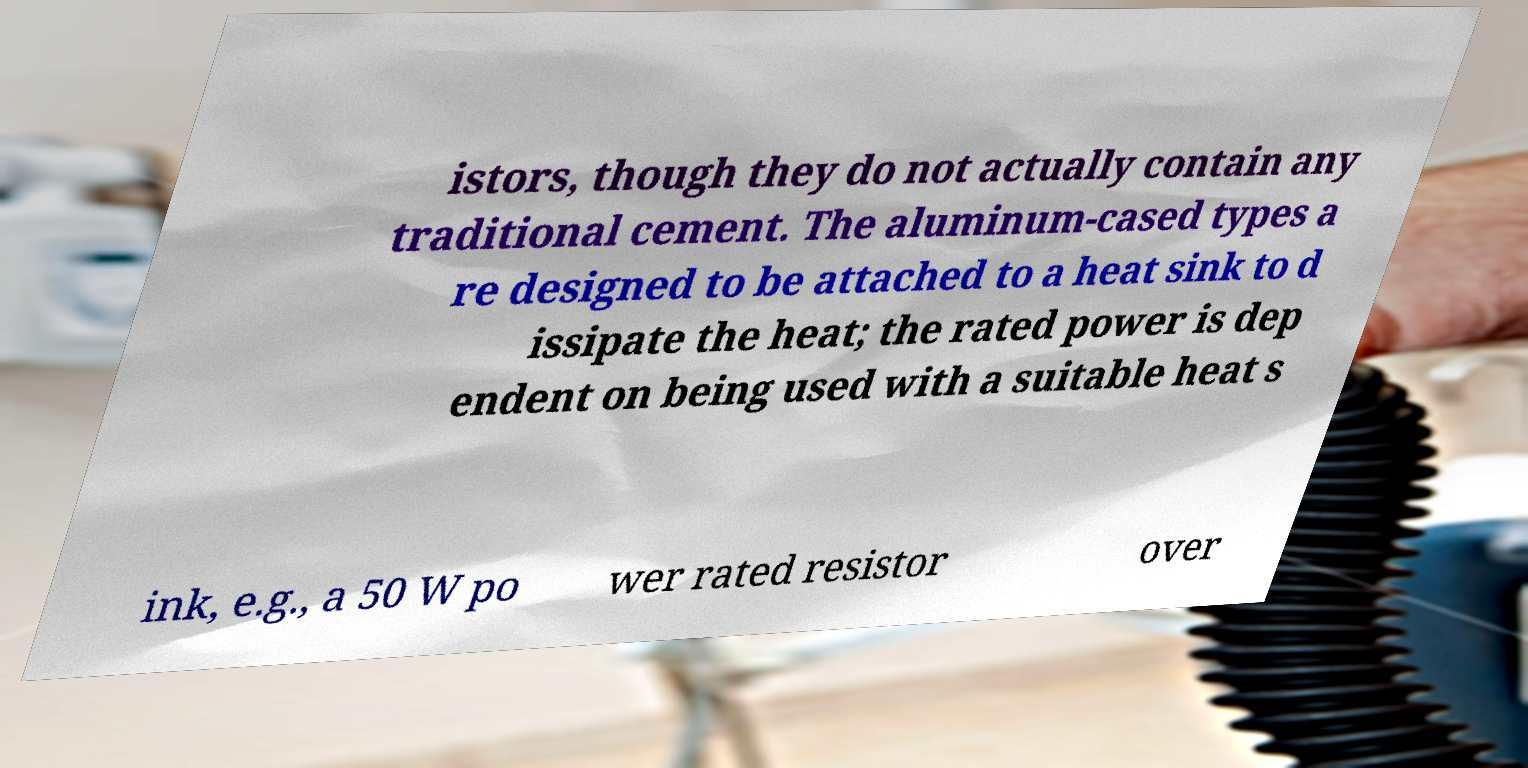Could you assist in decoding the text presented in this image and type it out clearly? istors, though they do not actually contain any traditional cement. The aluminum-cased types a re designed to be attached to a heat sink to d issipate the heat; the rated power is dep endent on being used with a suitable heat s ink, e.g., a 50 W po wer rated resistor over 